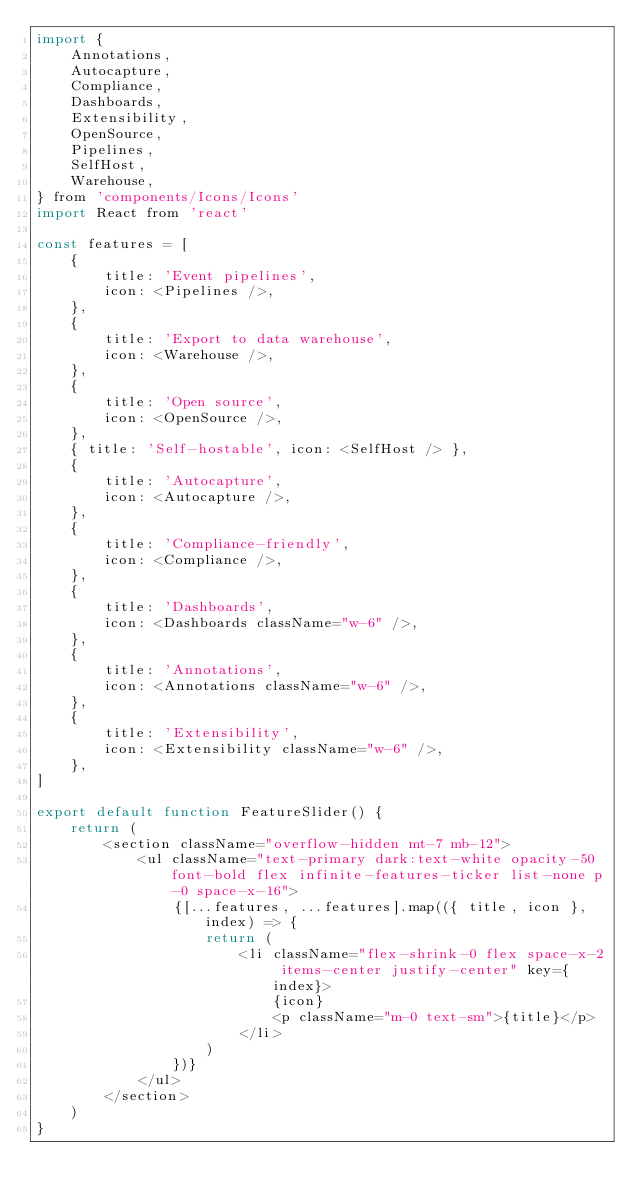Convert code to text. <code><loc_0><loc_0><loc_500><loc_500><_JavaScript_>import {
    Annotations,
    Autocapture,
    Compliance,
    Dashboards,
    Extensibility,
    OpenSource,
    Pipelines,
    SelfHost,
    Warehouse,
} from 'components/Icons/Icons'
import React from 'react'

const features = [
    {
        title: 'Event pipelines',
        icon: <Pipelines />,
    },
    {
        title: 'Export to data warehouse',
        icon: <Warehouse />,
    },
    {
        title: 'Open source',
        icon: <OpenSource />,
    },
    { title: 'Self-hostable', icon: <SelfHost /> },
    {
        title: 'Autocapture',
        icon: <Autocapture />,
    },
    {
        title: 'Compliance-friendly',
        icon: <Compliance />,
    },
    {
        title: 'Dashboards',
        icon: <Dashboards className="w-6" />,
    },
    {
        title: 'Annotations',
        icon: <Annotations className="w-6" />,
    },
    {
        title: 'Extensibility',
        icon: <Extensibility className="w-6" />,
    },
]

export default function FeatureSlider() {
    return (
        <section className="overflow-hidden mt-7 mb-12">
            <ul className="text-primary dark:text-white opacity-50 font-bold flex infinite-features-ticker list-none p-0 space-x-16">
                {[...features, ...features].map(({ title, icon }, index) => {
                    return (
                        <li className="flex-shrink-0 flex space-x-2 items-center justify-center" key={index}>
                            {icon}
                            <p className="m-0 text-sm">{title}</p>
                        </li>
                    )
                })}
            </ul>
        </section>
    )
}
</code> 